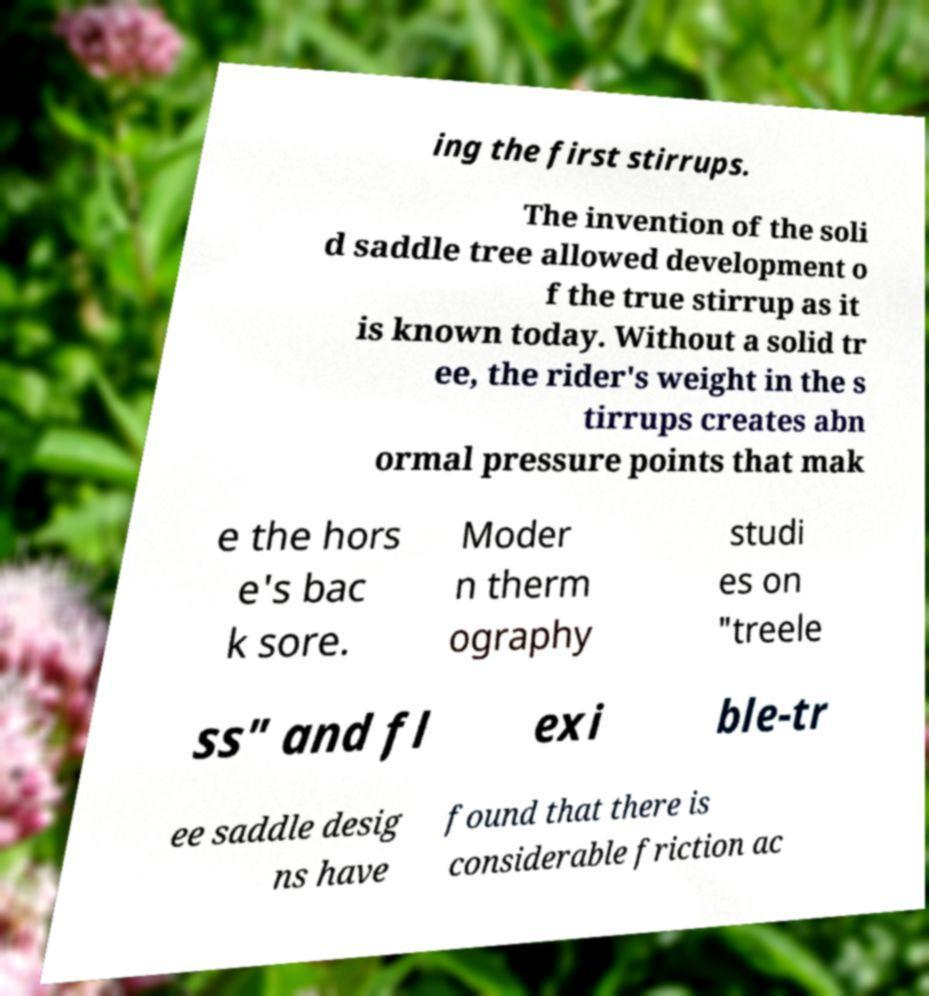Please read and relay the text visible in this image. What does it say? ing the first stirrups. The invention of the soli d saddle tree allowed development o f the true stirrup as it is known today. Without a solid tr ee, the rider's weight in the s tirrups creates abn ormal pressure points that mak e the hors e's bac k sore. Moder n therm ography studi es on "treele ss" and fl exi ble-tr ee saddle desig ns have found that there is considerable friction ac 